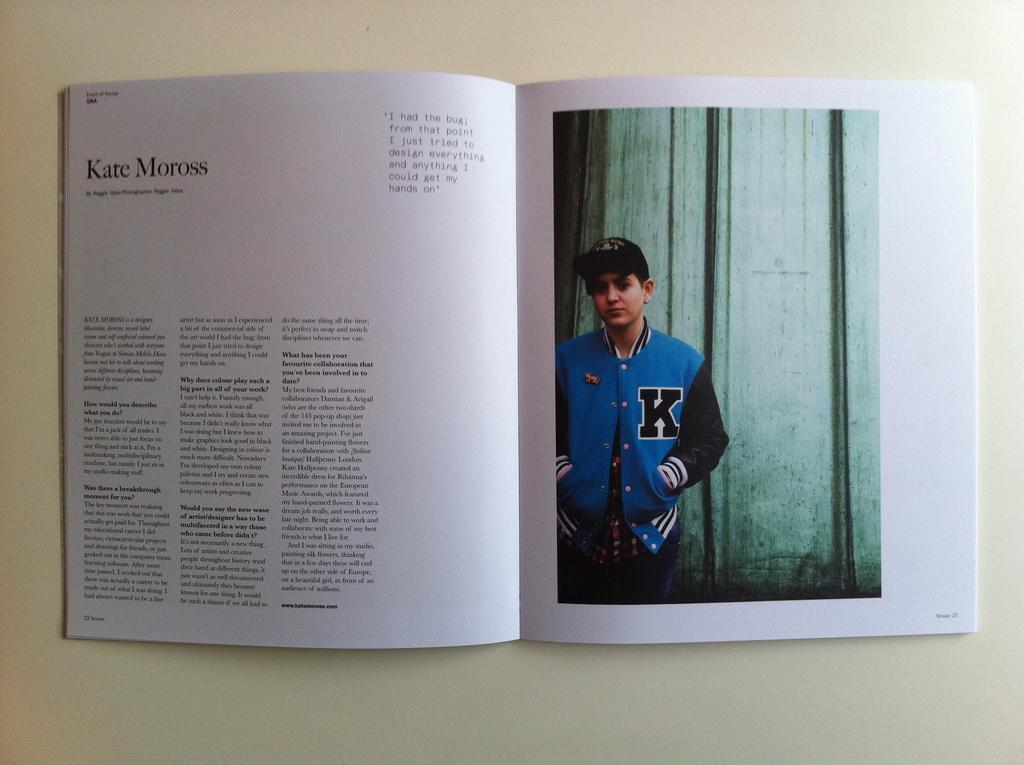<image>
Give a short and clear explanation of the subsequent image. the letter K is on the blue jacket of the person 